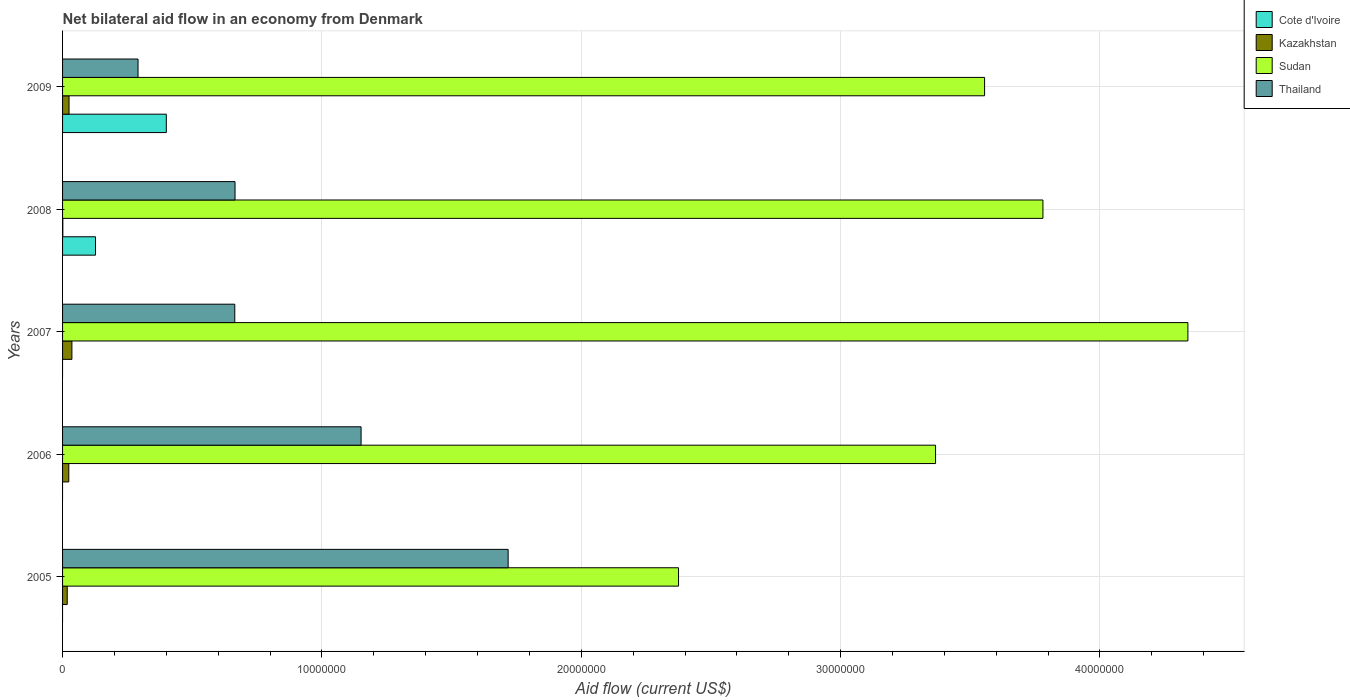Across all years, what is the minimum net bilateral aid flow in Sudan?
Your answer should be very brief. 2.38e+07. What is the total net bilateral aid flow in Kazakhstan in the graph?
Keep it short and to the point. 1.04e+06. What is the difference between the net bilateral aid flow in Thailand in 2006 and that in 2008?
Ensure brevity in your answer.  4.86e+06. What is the difference between the net bilateral aid flow in Thailand in 2005 and the net bilateral aid flow in Kazakhstan in 2008?
Offer a very short reply. 1.72e+07. What is the average net bilateral aid flow in Cote d'Ivoire per year?
Provide a succinct answer. 1.05e+06. In the year 2009, what is the difference between the net bilateral aid flow in Kazakhstan and net bilateral aid flow in Thailand?
Offer a very short reply. -2.66e+06. In how many years, is the net bilateral aid flow in Cote d'Ivoire greater than 10000000 US$?
Ensure brevity in your answer.  0. What is the ratio of the net bilateral aid flow in Thailand in 2005 to that in 2006?
Your answer should be compact. 1.49. Is the net bilateral aid flow in Thailand in 2008 less than that in 2009?
Make the answer very short. No. Is the difference between the net bilateral aid flow in Kazakhstan in 2005 and 2007 greater than the difference between the net bilateral aid flow in Thailand in 2005 and 2007?
Provide a succinct answer. No. What is the difference between the highest and the lowest net bilateral aid flow in Thailand?
Offer a terse response. 1.43e+07. In how many years, is the net bilateral aid flow in Thailand greater than the average net bilateral aid flow in Thailand taken over all years?
Your answer should be very brief. 2. Is the sum of the net bilateral aid flow in Kazakhstan in 2005 and 2009 greater than the maximum net bilateral aid flow in Cote d'Ivoire across all years?
Provide a succinct answer. No. Is it the case that in every year, the sum of the net bilateral aid flow in Cote d'Ivoire and net bilateral aid flow in Thailand is greater than the net bilateral aid flow in Sudan?
Keep it short and to the point. No. Are all the bars in the graph horizontal?
Your response must be concise. Yes. How many years are there in the graph?
Your response must be concise. 5. Are the values on the major ticks of X-axis written in scientific E-notation?
Your response must be concise. No. Does the graph contain any zero values?
Give a very brief answer. Yes. Does the graph contain grids?
Offer a terse response. Yes. Where does the legend appear in the graph?
Keep it short and to the point. Top right. How many legend labels are there?
Your answer should be very brief. 4. How are the legend labels stacked?
Make the answer very short. Vertical. What is the title of the graph?
Give a very brief answer. Net bilateral aid flow in an economy from Denmark. What is the label or title of the X-axis?
Your response must be concise. Aid flow (current US$). What is the label or title of the Y-axis?
Make the answer very short. Years. What is the Aid flow (current US$) in Cote d'Ivoire in 2005?
Your response must be concise. 0. What is the Aid flow (current US$) in Sudan in 2005?
Ensure brevity in your answer.  2.38e+07. What is the Aid flow (current US$) of Thailand in 2005?
Keep it short and to the point. 1.72e+07. What is the Aid flow (current US$) of Cote d'Ivoire in 2006?
Your answer should be very brief. 0. What is the Aid flow (current US$) in Sudan in 2006?
Provide a succinct answer. 3.37e+07. What is the Aid flow (current US$) of Thailand in 2006?
Make the answer very short. 1.15e+07. What is the Aid flow (current US$) of Sudan in 2007?
Give a very brief answer. 4.34e+07. What is the Aid flow (current US$) of Thailand in 2007?
Provide a succinct answer. 6.64e+06. What is the Aid flow (current US$) in Cote d'Ivoire in 2008?
Provide a succinct answer. 1.27e+06. What is the Aid flow (current US$) in Sudan in 2008?
Offer a terse response. 3.78e+07. What is the Aid flow (current US$) of Thailand in 2008?
Your response must be concise. 6.65e+06. What is the Aid flow (current US$) of Kazakhstan in 2009?
Offer a very short reply. 2.50e+05. What is the Aid flow (current US$) of Sudan in 2009?
Your response must be concise. 3.56e+07. What is the Aid flow (current US$) in Thailand in 2009?
Your response must be concise. 2.91e+06. Across all years, what is the maximum Aid flow (current US$) in Sudan?
Provide a short and direct response. 4.34e+07. Across all years, what is the maximum Aid flow (current US$) of Thailand?
Your answer should be compact. 1.72e+07. Across all years, what is the minimum Aid flow (current US$) in Cote d'Ivoire?
Ensure brevity in your answer.  0. Across all years, what is the minimum Aid flow (current US$) of Kazakhstan?
Give a very brief answer. 10000. Across all years, what is the minimum Aid flow (current US$) in Sudan?
Give a very brief answer. 2.38e+07. Across all years, what is the minimum Aid flow (current US$) of Thailand?
Your answer should be very brief. 2.91e+06. What is the total Aid flow (current US$) of Cote d'Ivoire in the graph?
Make the answer very short. 5.27e+06. What is the total Aid flow (current US$) of Kazakhstan in the graph?
Provide a short and direct response. 1.04e+06. What is the total Aid flow (current US$) in Sudan in the graph?
Make the answer very short. 1.74e+08. What is the total Aid flow (current US$) in Thailand in the graph?
Provide a short and direct response. 4.49e+07. What is the difference between the Aid flow (current US$) in Sudan in 2005 and that in 2006?
Your answer should be compact. -9.91e+06. What is the difference between the Aid flow (current US$) of Thailand in 2005 and that in 2006?
Give a very brief answer. 5.67e+06. What is the difference between the Aid flow (current US$) of Kazakhstan in 2005 and that in 2007?
Make the answer very short. -1.80e+05. What is the difference between the Aid flow (current US$) in Sudan in 2005 and that in 2007?
Keep it short and to the point. -1.96e+07. What is the difference between the Aid flow (current US$) of Thailand in 2005 and that in 2007?
Your answer should be very brief. 1.05e+07. What is the difference between the Aid flow (current US$) in Kazakhstan in 2005 and that in 2008?
Keep it short and to the point. 1.70e+05. What is the difference between the Aid flow (current US$) of Sudan in 2005 and that in 2008?
Ensure brevity in your answer.  -1.40e+07. What is the difference between the Aid flow (current US$) in Thailand in 2005 and that in 2008?
Offer a very short reply. 1.05e+07. What is the difference between the Aid flow (current US$) in Sudan in 2005 and that in 2009?
Make the answer very short. -1.18e+07. What is the difference between the Aid flow (current US$) in Thailand in 2005 and that in 2009?
Keep it short and to the point. 1.43e+07. What is the difference between the Aid flow (current US$) in Kazakhstan in 2006 and that in 2007?
Ensure brevity in your answer.  -1.20e+05. What is the difference between the Aid flow (current US$) in Sudan in 2006 and that in 2007?
Provide a short and direct response. -9.73e+06. What is the difference between the Aid flow (current US$) in Thailand in 2006 and that in 2007?
Offer a very short reply. 4.87e+06. What is the difference between the Aid flow (current US$) of Kazakhstan in 2006 and that in 2008?
Your answer should be compact. 2.30e+05. What is the difference between the Aid flow (current US$) in Sudan in 2006 and that in 2008?
Your answer should be compact. -4.14e+06. What is the difference between the Aid flow (current US$) in Thailand in 2006 and that in 2008?
Offer a terse response. 4.86e+06. What is the difference between the Aid flow (current US$) in Kazakhstan in 2006 and that in 2009?
Ensure brevity in your answer.  -10000. What is the difference between the Aid flow (current US$) of Sudan in 2006 and that in 2009?
Offer a terse response. -1.89e+06. What is the difference between the Aid flow (current US$) in Thailand in 2006 and that in 2009?
Offer a very short reply. 8.60e+06. What is the difference between the Aid flow (current US$) of Sudan in 2007 and that in 2008?
Offer a very short reply. 5.59e+06. What is the difference between the Aid flow (current US$) of Kazakhstan in 2007 and that in 2009?
Offer a very short reply. 1.10e+05. What is the difference between the Aid flow (current US$) of Sudan in 2007 and that in 2009?
Your answer should be compact. 7.84e+06. What is the difference between the Aid flow (current US$) of Thailand in 2007 and that in 2009?
Provide a succinct answer. 3.73e+06. What is the difference between the Aid flow (current US$) of Cote d'Ivoire in 2008 and that in 2009?
Offer a terse response. -2.73e+06. What is the difference between the Aid flow (current US$) of Kazakhstan in 2008 and that in 2009?
Provide a short and direct response. -2.40e+05. What is the difference between the Aid flow (current US$) in Sudan in 2008 and that in 2009?
Keep it short and to the point. 2.25e+06. What is the difference between the Aid flow (current US$) of Thailand in 2008 and that in 2009?
Provide a succinct answer. 3.74e+06. What is the difference between the Aid flow (current US$) of Kazakhstan in 2005 and the Aid flow (current US$) of Sudan in 2006?
Keep it short and to the point. -3.35e+07. What is the difference between the Aid flow (current US$) in Kazakhstan in 2005 and the Aid flow (current US$) in Thailand in 2006?
Ensure brevity in your answer.  -1.13e+07. What is the difference between the Aid flow (current US$) of Sudan in 2005 and the Aid flow (current US$) of Thailand in 2006?
Provide a short and direct response. 1.22e+07. What is the difference between the Aid flow (current US$) in Kazakhstan in 2005 and the Aid flow (current US$) in Sudan in 2007?
Your answer should be compact. -4.32e+07. What is the difference between the Aid flow (current US$) in Kazakhstan in 2005 and the Aid flow (current US$) in Thailand in 2007?
Ensure brevity in your answer.  -6.46e+06. What is the difference between the Aid flow (current US$) in Sudan in 2005 and the Aid flow (current US$) in Thailand in 2007?
Your answer should be very brief. 1.71e+07. What is the difference between the Aid flow (current US$) in Kazakhstan in 2005 and the Aid flow (current US$) in Sudan in 2008?
Offer a very short reply. -3.76e+07. What is the difference between the Aid flow (current US$) of Kazakhstan in 2005 and the Aid flow (current US$) of Thailand in 2008?
Provide a succinct answer. -6.47e+06. What is the difference between the Aid flow (current US$) in Sudan in 2005 and the Aid flow (current US$) in Thailand in 2008?
Keep it short and to the point. 1.71e+07. What is the difference between the Aid flow (current US$) of Kazakhstan in 2005 and the Aid flow (current US$) of Sudan in 2009?
Offer a terse response. -3.54e+07. What is the difference between the Aid flow (current US$) in Kazakhstan in 2005 and the Aid flow (current US$) in Thailand in 2009?
Ensure brevity in your answer.  -2.73e+06. What is the difference between the Aid flow (current US$) in Sudan in 2005 and the Aid flow (current US$) in Thailand in 2009?
Your answer should be compact. 2.08e+07. What is the difference between the Aid flow (current US$) of Kazakhstan in 2006 and the Aid flow (current US$) of Sudan in 2007?
Give a very brief answer. -4.32e+07. What is the difference between the Aid flow (current US$) of Kazakhstan in 2006 and the Aid flow (current US$) of Thailand in 2007?
Your answer should be very brief. -6.40e+06. What is the difference between the Aid flow (current US$) of Sudan in 2006 and the Aid flow (current US$) of Thailand in 2007?
Offer a very short reply. 2.70e+07. What is the difference between the Aid flow (current US$) in Kazakhstan in 2006 and the Aid flow (current US$) in Sudan in 2008?
Provide a short and direct response. -3.76e+07. What is the difference between the Aid flow (current US$) in Kazakhstan in 2006 and the Aid flow (current US$) in Thailand in 2008?
Your answer should be compact. -6.41e+06. What is the difference between the Aid flow (current US$) of Sudan in 2006 and the Aid flow (current US$) of Thailand in 2008?
Your answer should be very brief. 2.70e+07. What is the difference between the Aid flow (current US$) of Kazakhstan in 2006 and the Aid flow (current US$) of Sudan in 2009?
Make the answer very short. -3.53e+07. What is the difference between the Aid flow (current US$) of Kazakhstan in 2006 and the Aid flow (current US$) of Thailand in 2009?
Ensure brevity in your answer.  -2.67e+06. What is the difference between the Aid flow (current US$) of Sudan in 2006 and the Aid flow (current US$) of Thailand in 2009?
Keep it short and to the point. 3.08e+07. What is the difference between the Aid flow (current US$) of Kazakhstan in 2007 and the Aid flow (current US$) of Sudan in 2008?
Make the answer very short. -3.74e+07. What is the difference between the Aid flow (current US$) of Kazakhstan in 2007 and the Aid flow (current US$) of Thailand in 2008?
Your response must be concise. -6.29e+06. What is the difference between the Aid flow (current US$) of Sudan in 2007 and the Aid flow (current US$) of Thailand in 2008?
Ensure brevity in your answer.  3.67e+07. What is the difference between the Aid flow (current US$) in Kazakhstan in 2007 and the Aid flow (current US$) in Sudan in 2009?
Your response must be concise. -3.52e+07. What is the difference between the Aid flow (current US$) in Kazakhstan in 2007 and the Aid flow (current US$) in Thailand in 2009?
Your answer should be very brief. -2.55e+06. What is the difference between the Aid flow (current US$) of Sudan in 2007 and the Aid flow (current US$) of Thailand in 2009?
Ensure brevity in your answer.  4.05e+07. What is the difference between the Aid flow (current US$) in Cote d'Ivoire in 2008 and the Aid flow (current US$) in Kazakhstan in 2009?
Provide a succinct answer. 1.02e+06. What is the difference between the Aid flow (current US$) of Cote d'Ivoire in 2008 and the Aid flow (current US$) of Sudan in 2009?
Provide a short and direct response. -3.43e+07. What is the difference between the Aid flow (current US$) in Cote d'Ivoire in 2008 and the Aid flow (current US$) in Thailand in 2009?
Make the answer very short. -1.64e+06. What is the difference between the Aid flow (current US$) in Kazakhstan in 2008 and the Aid flow (current US$) in Sudan in 2009?
Offer a very short reply. -3.55e+07. What is the difference between the Aid flow (current US$) in Kazakhstan in 2008 and the Aid flow (current US$) in Thailand in 2009?
Your answer should be very brief. -2.90e+06. What is the difference between the Aid flow (current US$) of Sudan in 2008 and the Aid flow (current US$) of Thailand in 2009?
Ensure brevity in your answer.  3.49e+07. What is the average Aid flow (current US$) of Cote d'Ivoire per year?
Your response must be concise. 1.05e+06. What is the average Aid flow (current US$) of Kazakhstan per year?
Provide a short and direct response. 2.08e+05. What is the average Aid flow (current US$) of Sudan per year?
Your answer should be compact. 3.48e+07. What is the average Aid flow (current US$) in Thailand per year?
Your response must be concise. 8.98e+06. In the year 2005, what is the difference between the Aid flow (current US$) of Kazakhstan and Aid flow (current US$) of Sudan?
Ensure brevity in your answer.  -2.36e+07. In the year 2005, what is the difference between the Aid flow (current US$) of Kazakhstan and Aid flow (current US$) of Thailand?
Your response must be concise. -1.70e+07. In the year 2005, what is the difference between the Aid flow (current US$) of Sudan and Aid flow (current US$) of Thailand?
Your answer should be compact. 6.57e+06. In the year 2006, what is the difference between the Aid flow (current US$) of Kazakhstan and Aid flow (current US$) of Sudan?
Your answer should be very brief. -3.34e+07. In the year 2006, what is the difference between the Aid flow (current US$) in Kazakhstan and Aid flow (current US$) in Thailand?
Make the answer very short. -1.13e+07. In the year 2006, what is the difference between the Aid flow (current US$) in Sudan and Aid flow (current US$) in Thailand?
Offer a terse response. 2.22e+07. In the year 2007, what is the difference between the Aid flow (current US$) in Kazakhstan and Aid flow (current US$) in Sudan?
Offer a very short reply. -4.30e+07. In the year 2007, what is the difference between the Aid flow (current US$) of Kazakhstan and Aid flow (current US$) of Thailand?
Offer a very short reply. -6.28e+06. In the year 2007, what is the difference between the Aid flow (current US$) of Sudan and Aid flow (current US$) of Thailand?
Your answer should be compact. 3.68e+07. In the year 2008, what is the difference between the Aid flow (current US$) in Cote d'Ivoire and Aid flow (current US$) in Kazakhstan?
Provide a succinct answer. 1.26e+06. In the year 2008, what is the difference between the Aid flow (current US$) in Cote d'Ivoire and Aid flow (current US$) in Sudan?
Your response must be concise. -3.65e+07. In the year 2008, what is the difference between the Aid flow (current US$) of Cote d'Ivoire and Aid flow (current US$) of Thailand?
Offer a very short reply. -5.38e+06. In the year 2008, what is the difference between the Aid flow (current US$) in Kazakhstan and Aid flow (current US$) in Sudan?
Provide a short and direct response. -3.78e+07. In the year 2008, what is the difference between the Aid flow (current US$) in Kazakhstan and Aid flow (current US$) in Thailand?
Your response must be concise. -6.64e+06. In the year 2008, what is the difference between the Aid flow (current US$) in Sudan and Aid flow (current US$) in Thailand?
Make the answer very short. 3.12e+07. In the year 2009, what is the difference between the Aid flow (current US$) of Cote d'Ivoire and Aid flow (current US$) of Kazakhstan?
Your answer should be very brief. 3.75e+06. In the year 2009, what is the difference between the Aid flow (current US$) of Cote d'Ivoire and Aid flow (current US$) of Sudan?
Make the answer very short. -3.16e+07. In the year 2009, what is the difference between the Aid flow (current US$) in Cote d'Ivoire and Aid flow (current US$) in Thailand?
Your answer should be very brief. 1.09e+06. In the year 2009, what is the difference between the Aid flow (current US$) in Kazakhstan and Aid flow (current US$) in Sudan?
Provide a succinct answer. -3.53e+07. In the year 2009, what is the difference between the Aid flow (current US$) in Kazakhstan and Aid flow (current US$) in Thailand?
Your answer should be compact. -2.66e+06. In the year 2009, what is the difference between the Aid flow (current US$) in Sudan and Aid flow (current US$) in Thailand?
Your answer should be very brief. 3.26e+07. What is the ratio of the Aid flow (current US$) in Kazakhstan in 2005 to that in 2006?
Your answer should be compact. 0.75. What is the ratio of the Aid flow (current US$) in Sudan in 2005 to that in 2006?
Keep it short and to the point. 0.71. What is the ratio of the Aid flow (current US$) in Thailand in 2005 to that in 2006?
Your answer should be compact. 1.49. What is the ratio of the Aid flow (current US$) in Kazakhstan in 2005 to that in 2007?
Ensure brevity in your answer.  0.5. What is the ratio of the Aid flow (current US$) in Sudan in 2005 to that in 2007?
Make the answer very short. 0.55. What is the ratio of the Aid flow (current US$) of Thailand in 2005 to that in 2007?
Provide a succinct answer. 2.59. What is the ratio of the Aid flow (current US$) of Sudan in 2005 to that in 2008?
Provide a short and direct response. 0.63. What is the ratio of the Aid flow (current US$) in Thailand in 2005 to that in 2008?
Offer a very short reply. 2.58. What is the ratio of the Aid flow (current US$) of Kazakhstan in 2005 to that in 2009?
Give a very brief answer. 0.72. What is the ratio of the Aid flow (current US$) of Sudan in 2005 to that in 2009?
Provide a succinct answer. 0.67. What is the ratio of the Aid flow (current US$) of Thailand in 2005 to that in 2009?
Ensure brevity in your answer.  5.9. What is the ratio of the Aid flow (current US$) of Sudan in 2006 to that in 2007?
Keep it short and to the point. 0.78. What is the ratio of the Aid flow (current US$) in Thailand in 2006 to that in 2007?
Offer a terse response. 1.73. What is the ratio of the Aid flow (current US$) of Kazakhstan in 2006 to that in 2008?
Ensure brevity in your answer.  24. What is the ratio of the Aid flow (current US$) in Sudan in 2006 to that in 2008?
Offer a very short reply. 0.89. What is the ratio of the Aid flow (current US$) in Thailand in 2006 to that in 2008?
Provide a short and direct response. 1.73. What is the ratio of the Aid flow (current US$) in Sudan in 2006 to that in 2009?
Make the answer very short. 0.95. What is the ratio of the Aid flow (current US$) in Thailand in 2006 to that in 2009?
Make the answer very short. 3.96. What is the ratio of the Aid flow (current US$) in Kazakhstan in 2007 to that in 2008?
Give a very brief answer. 36. What is the ratio of the Aid flow (current US$) of Sudan in 2007 to that in 2008?
Your answer should be compact. 1.15. What is the ratio of the Aid flow (current US$) of Thailand in 2007 to that in 2008?
Offer a very short reply. 1. What is the ratio of the Aid flow (current US$) of Kazakhstan in 2007 to that in 2009?
Ensure brevity in your answer.  1.44. What is the ratio of the Aid flow (current US$) of Sudan in 2007 to that in 2009?
Your answer should be compact. 1.22. What is the ratio of the Aid flow (current US$) of Thailand in 2007 to that in 2009?
Your answer should be very brief. 2.28. What is the ratio of the Aid flow (current US$) in Cote d'Ivoire in 2008 to that in 2009?
Give a very brief answer. 0.32. What is the ratio of the Aid flow (current US$) in Kazakhstan in 2008 to that in 2009?
Give a very brief answer. 0.04. What is the ratio of the Aid flow (current US$) in Sudan in 2008 to that in 2009?
Your answer should be compact. 1.06. What is the ratio of the Aid flow (current US$) of Thailand in 2008 to that in 2009?
Give a very brief answer. 2.29. What is the difference between the highest and the second highest Aid flow (current US$) of Kazakhstan?
Your answer should be very brief. 1.10e+05. What is the difference between the highest and the second highest Aid flow (current US$) in Sudan?
Your response must be concise. 5.59e+06. What is the difference between the highest and the second highest Aid flow (current US$) in Thailand?
Provide a short and direct response. 5.67e+06. What is the difference between the highest and the lowest Aid flow (current US$) in Cote d'Ivoire?
Keep it short and to the point. 4.00e+06. What is the difference between the highest and the lowest Aid flow (current US$) in Sudan?
Offer a very short reply. 1.96e+07. What is the difference between the highest and the lowest Aid flow (current US$) in Thailand?
Keep it short and to the point. 1.43e+07. 